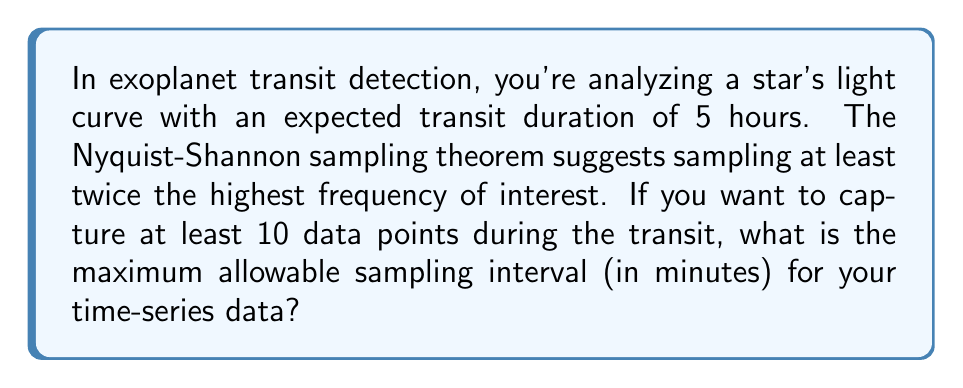Could you help me with this problem? To solve this problem, we need to follow these steps:

1) First, let's consider the transit duration:
   Transit duration = 5 hours = 300 minutes

2) We want to capture at least 10 data points during this transit. This means we need to divide the transit duration by 10:
   
   $$\text{Time between samples} = \frac{300 \text{ minutes}}{10} = 30 \text{ minutes}$$

3) However, the Nyquist-Shannon sampling theorem states that we should sample at least twice the highest frequency of interest. In this case, that means we should sample at least twice as frequently as the rate we calculated:

   $$\text{Maximum sampling interval} = \frac{30 \text{ minutes}}{2} = 15 \text{ minutes}$$

4) Therefore, to ensure we capture at least 10 data points during the transit and satisfy the Nyquist-Shannon theorem, we should sample no less frequently than every 15 minutes.

This sampling rate will allow us to accurately reconstruct the light curve and detect the transit while avoiding aliasing effects that could occur with a lower sampling rate.
Answer: The maximum allowable sampling interval is 15 minutes. 